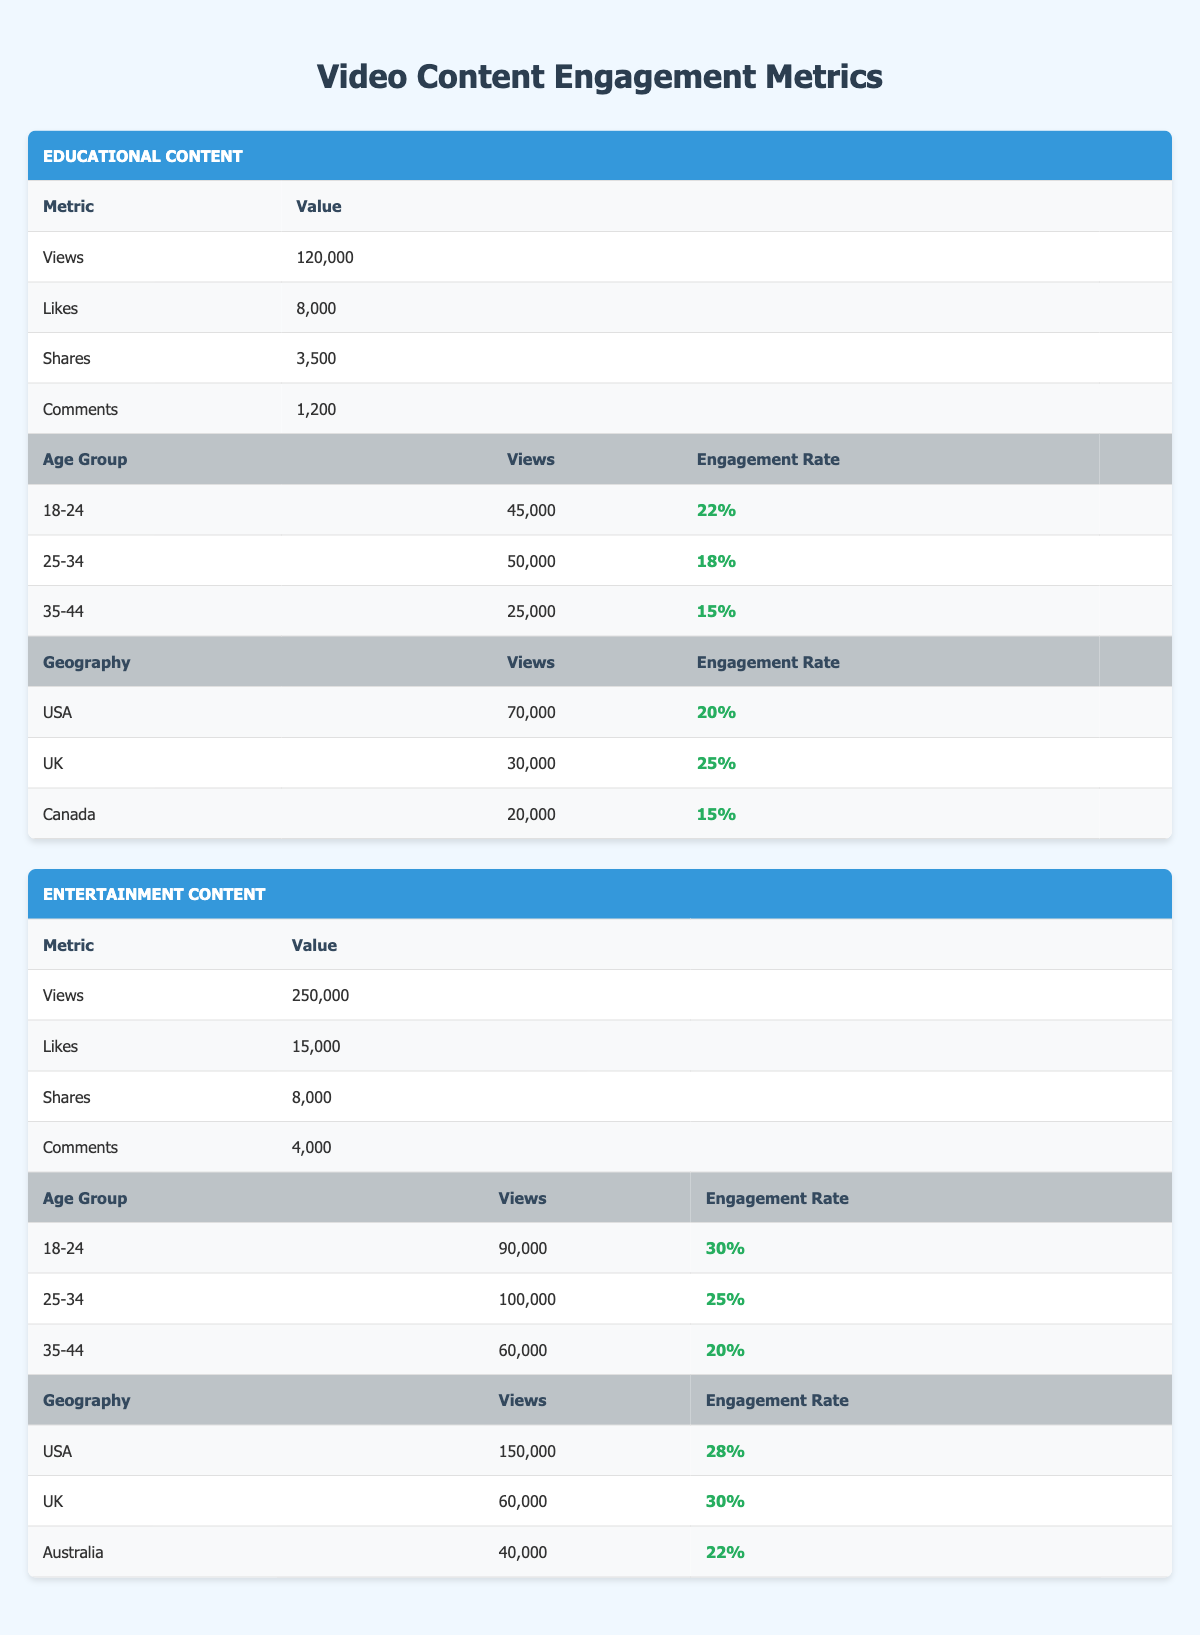What is the total number of views for Educational content? The total number of views for Educational content can be found directly in the table under the Educational section, which lists 120,000 views.
Answer: 120,000 Which age group has the highest engagement rate for Entertainment content? By examining the engagement rates of the age groups listed for Entertainment content, we can see that the 18-24 age group has the highest engagement rate at 30%.
Answer: 18-24 How many more likes does Entertainment content have compared to Educational content? The Entertainment content has 15,000 likes, while the Educational content has 8,000 likes. To find the difference, subtract the number of likes of Educational content from that of Entertainment content: 15,000 - 8,000 = 7,000.
Answer: 7,000 Is the engagement rate for the UK audience higher in Entertainment content than in Educational content? For Educational content, the engagement rate for the UK is 25%. For Entertainment content, the engagement rate for the UK is 30%. Since 30% is greater than 25%, the engagement rate in Entertainment is indeed higher.
Answer: Yes What percentage of the total views of Entertainment content comes from the USA? The total views for Entertainment content is 250,000, and the views from the USA are 150,000. To find the percentage, we calculate (150,000 / 250,000) * 100 = 60%.
Answer: 60% Which content type has a higher total number of shares and by how much? Educational content has 3,500 shares, while Entertainment content has 8,000 shares. To determine which has more, subtract Educational shares from Entertainment shares: 8,000 - 3,500 = 4,500. Thus, Entertainment content has 4,500 more shares.
Answer: Entertainment has 4,500 more shares What is the average engagement rate for the 25-34 age group across both content types? The engagement rate for Educational content in the 25-34 age group is 18%, and for Entertainment content, it is 25%. To find the average, sum these rates (18% + 25% = 43%) and divide by 2 (43% / 2 = 21.5%).
Answer: 21.5% How many total comments were received for both content types combined? The total comments for Educational content is 1,200 and for Entertainment content is 4,000. To find the total, sum both values: 1,200 + 4,000 = 5,200.
Answer: 5,200 Is the total number of views for the 35-44 age group in Educational content greater than that for the same age group in Entertainment content? The table shows that the views for the 35-44 age group in Educational content is 25,000, while in Entertainment content it is 60,000. Since 25,000 is less than 60,000, the statement is false.
Answer: No 